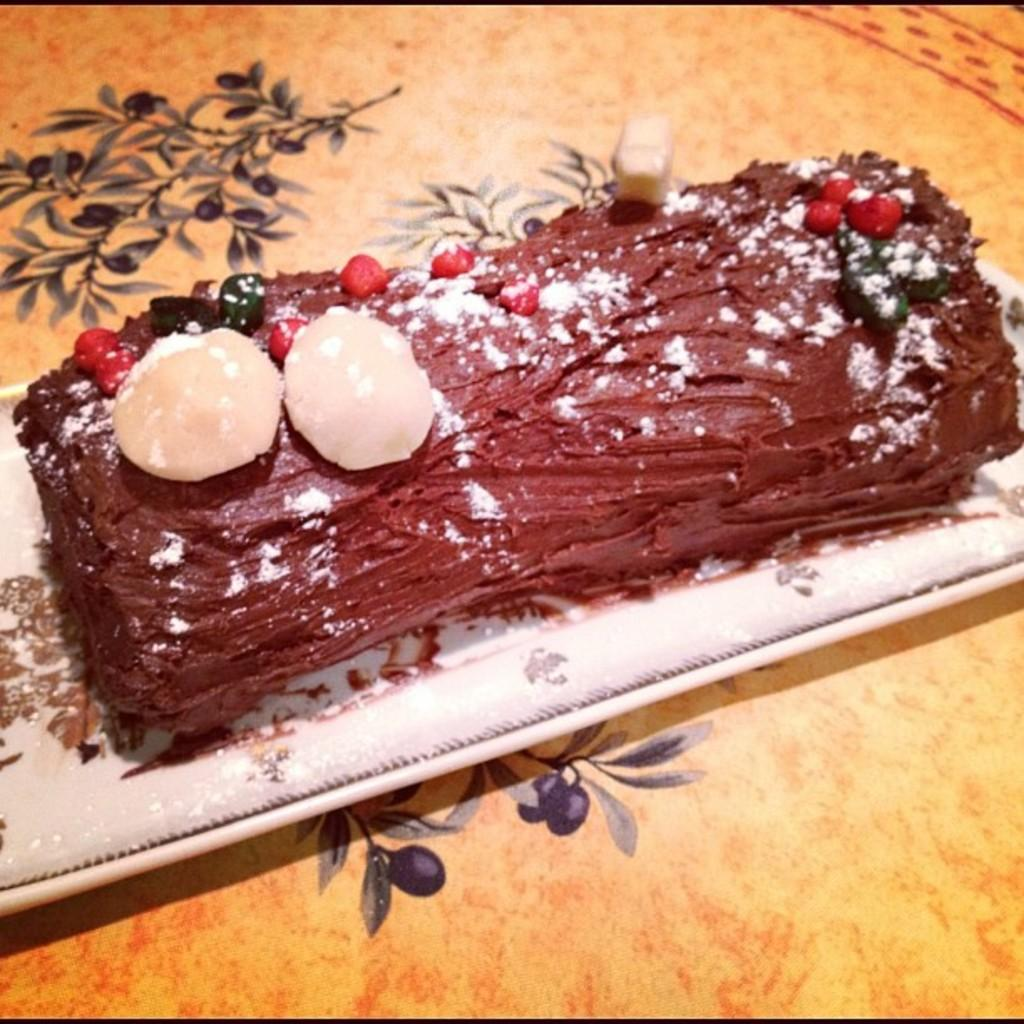What is on the serving plate in the image? The serving plate contains dessert. Where is the serving plate located? The serving plate is placed on a table. What type of food is on the serving plate? The dessert on the serving plate is not specified, but it is a type of dessert. Can you hear anyone laughing at the seashore in the image? There is no reference to laughter, a seashore, or any sound in the image, so it's not possible to determine if anyone is laughing at the seashore. 